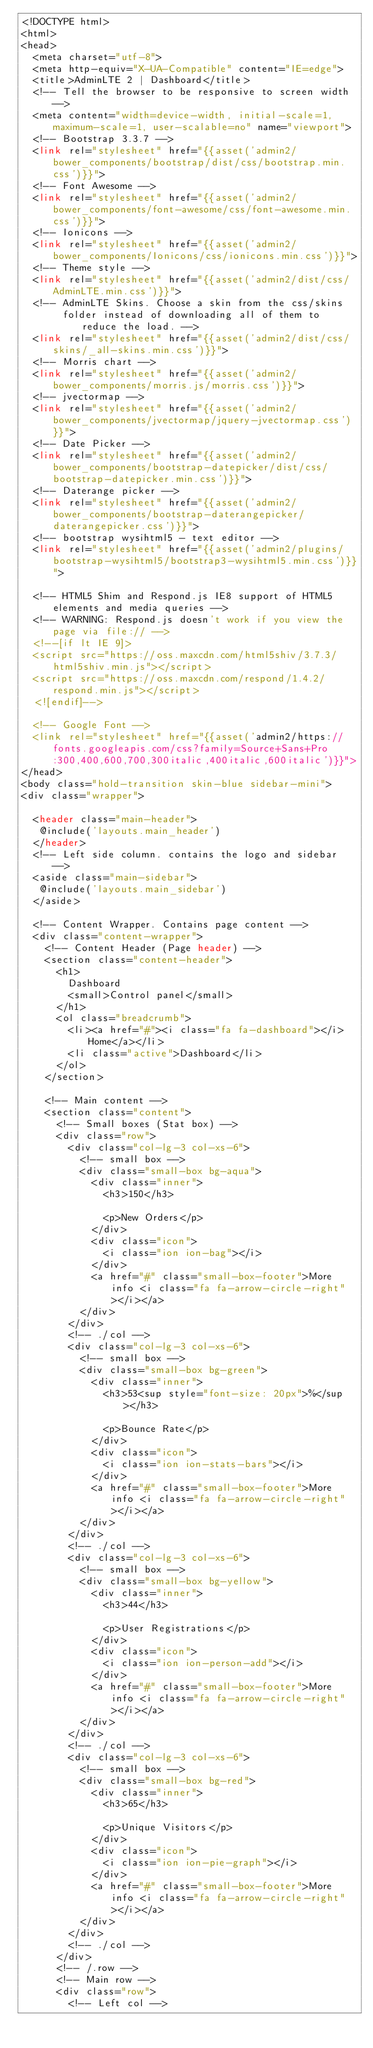<code> <loc_0><loc_0><loc_500><loc_500><_PHP_><!DOCTYPE html>
<html>
<head>
  <meta charset="utf-8">
  <meta http-equiv="X-UA-Compatible" content="IE=edge">
  <title>AdminLTE 2 | Dashboard</title>
  <!-- Tell the browser to be responsive to screen width -->
  <meta content="width=device-width, initial-scale=1, maximum-scale=1, user-scalable=no" name="viewport">
  <!-- Bootstrap 3.3.7 -->
  <link rel="stylesheet" href="{{asset('admin2/bower_components/bootstrap/dist/css/bootstrap.min.css')}}">
  <!-- Font Awesome -->
  <link rel="stylesheet" href="{{asset('admin2/bower_components/font-awesome/css/font-awesome.min.css')}}">
  <!-- Ionicons -->
  <link rel="stylesheet" href="{{asset('admin2/bower_components/Ionicons/css/ionicons.min.css')}}">
  <!-- Theme style -->
  <link rel="stylesheet" href="{{asset('admin2/dist/css/AdminLTE.min.css')}}">
  <!-- AdminLTE Skins. Choose a skin from the css/skins
       folder instead of downloading all of them to reduce the load. -->
  <link rel="stylesheet" href="{{asset('admin2/dist/css/skins/_all-skins.min.css')}}">
  <!-- Morris chart -->
  <link rel="stylesheet" href="{{asset('admin2/bower_components/morris.js/morris.css')}}">
  <!-- jvectormap -->
  <link rel="stylesheet" href="{{asset('admin2/bower_components/jvectormap/jquery-jvectormap.css')}}">
  <!-- Date Picker -->
  <link rel="stylesheet" href="{{asset('admin2/bower_components/bootstrap-datepicker/dist/css/bootstrap-datepicker.min.css')}}">
  <!-- Daterange picker -->
  <link rel="stylesheet" href="{{asset('admin2/bower_components/bootstrap-daterangepicker/daterangepicker.css')}}">
  <!-- bootstrap wysihtml5 - text editor -->
  <link rel="stylesheet" href="{{asset('admin2/plugins/bootstrap-wysihtml5/bootstrap3-wysihtml5.min.css')}}">

  <!-- HTML5 Shim and Respond.js IE8 support of HTML5 elements and media queries -->
  <!-- WARNING: Respond.js doesn't work if you view the page via file:// -->
  <!--[if lt IE 9]>
  <script src="https://oss.maxcdn.com/html5shiv/3.7.3/html5shiv.min.js"></script>
  <script src="https://oss.maxcdn.com/respond/1.4.2/respond.min.js"></script>
  <![endif]-->

  <!-- Google Font -->
  <link rel="stylesheet" href="{{asset('admin2/https://fonts.googleapis.com/css?family=Source+Sans+Pro:300,400,600,700,300italic,400italic,600italic')}}">
</head>
<body class="hold-transition skin-blue sidebar-mini">
<div class="wrapper">

  <header class="main-header">
   @include('layouts.main_header')
  </header>
  <!-- Left side column. contains the logo and sidebar -->
  <aside class="main-sidebar">
   @include('layouts.main_sidebar')
  </aside>

  <!-- Content Wrapper. Contains page content -->
  <div class="content-wrapper">
    <!-- Content Header (Page header) -->
    <section class="content-header">
      <h1>
        Dashboard
        <small>Control panel</small>
      </h1>
      <ol class="breadcrumb">
        <li><a href="#"><i class="fa fa-dashboard"></i> Home</a></li>
        <li class="active">Dashboard</li>
      </ol>
    </section>

    <!-- Main content -->
    <section class="content">
      <!-- Small boxes (Stat box) -->
      <div class="row">
        <div class="col-lg-3 col-xs-6">
          <!-- small box -->
          <div class="small-box bg-aqua">
            <div class="inner">
              <h3>150</h3>

              <p>New Orders</p>
            </div>
            <div class="icon">
              <i class="ion ion-bag"></i>
            </div>
            <a href="#" class="small-box-footer">More info <i class="fa fa-arrow-circle-right"></i></a>
          </div>
        </div>
        <!-- ./col -->
        <div class="col-lg-3 col-xs-6">
          <!-- small box -->
          <div class="small-box bg-green">
            <div class="inner">
              <h3>53<sup style="font-size: 20px">%</sup></h3>

              <p>Bounce Rate</p>
            </div>
            <div class="icon">
              <i class="ion ion-stats-bars"></i>
            </div>
            <a href="#" class="small-box-footer">More info <i class="fa fa-arrow-circle-right"></i></a>
          </div>
        </div>
        <!-- ./col -->
        <div class="col-lg-3 col-xs-6">
          <!-- small box -->
          <div class="small-box bg-yellow">
            <div class="inner">
              <h3>44</h3>

              <p>User Registrations</p>
            </div>
            <div class="icon">
              <i class="ion ion-person-add"></i>
            </div>
            <a href="#" class="small-box-footer">More info <i class="fa fa-arrow-circle-right"></i></a>
          </div>
        </div>
        <!-- ./col -->
        <div class="col-lg-3 col-xs-6">
          <!-- small box -->
          <div class="small-box bg-red">
            <div class="inner">
              <h3>65</h3>

              <p>Unique Visitors</p>
            </div>
            <div class="icon">
              <i class="ion ion-pie-graph"></i>
            </div>
            <a href="#" class="small-box-footer">More info <i class="fa fa-arrow-circle-right"></i></a>
          </div>
        </div>
        <!-- ./col -->
      </div>
      <!-- /.row -->
      <!-- Main row -->
      <div class="row">
        <!-- Left col --></code> 